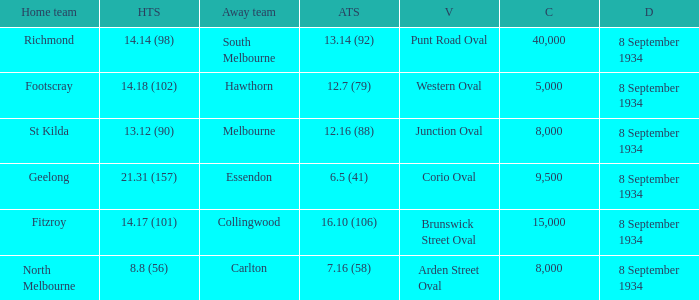When the Venue was Punt Road Oval, who was the Home Team? Richmond. 